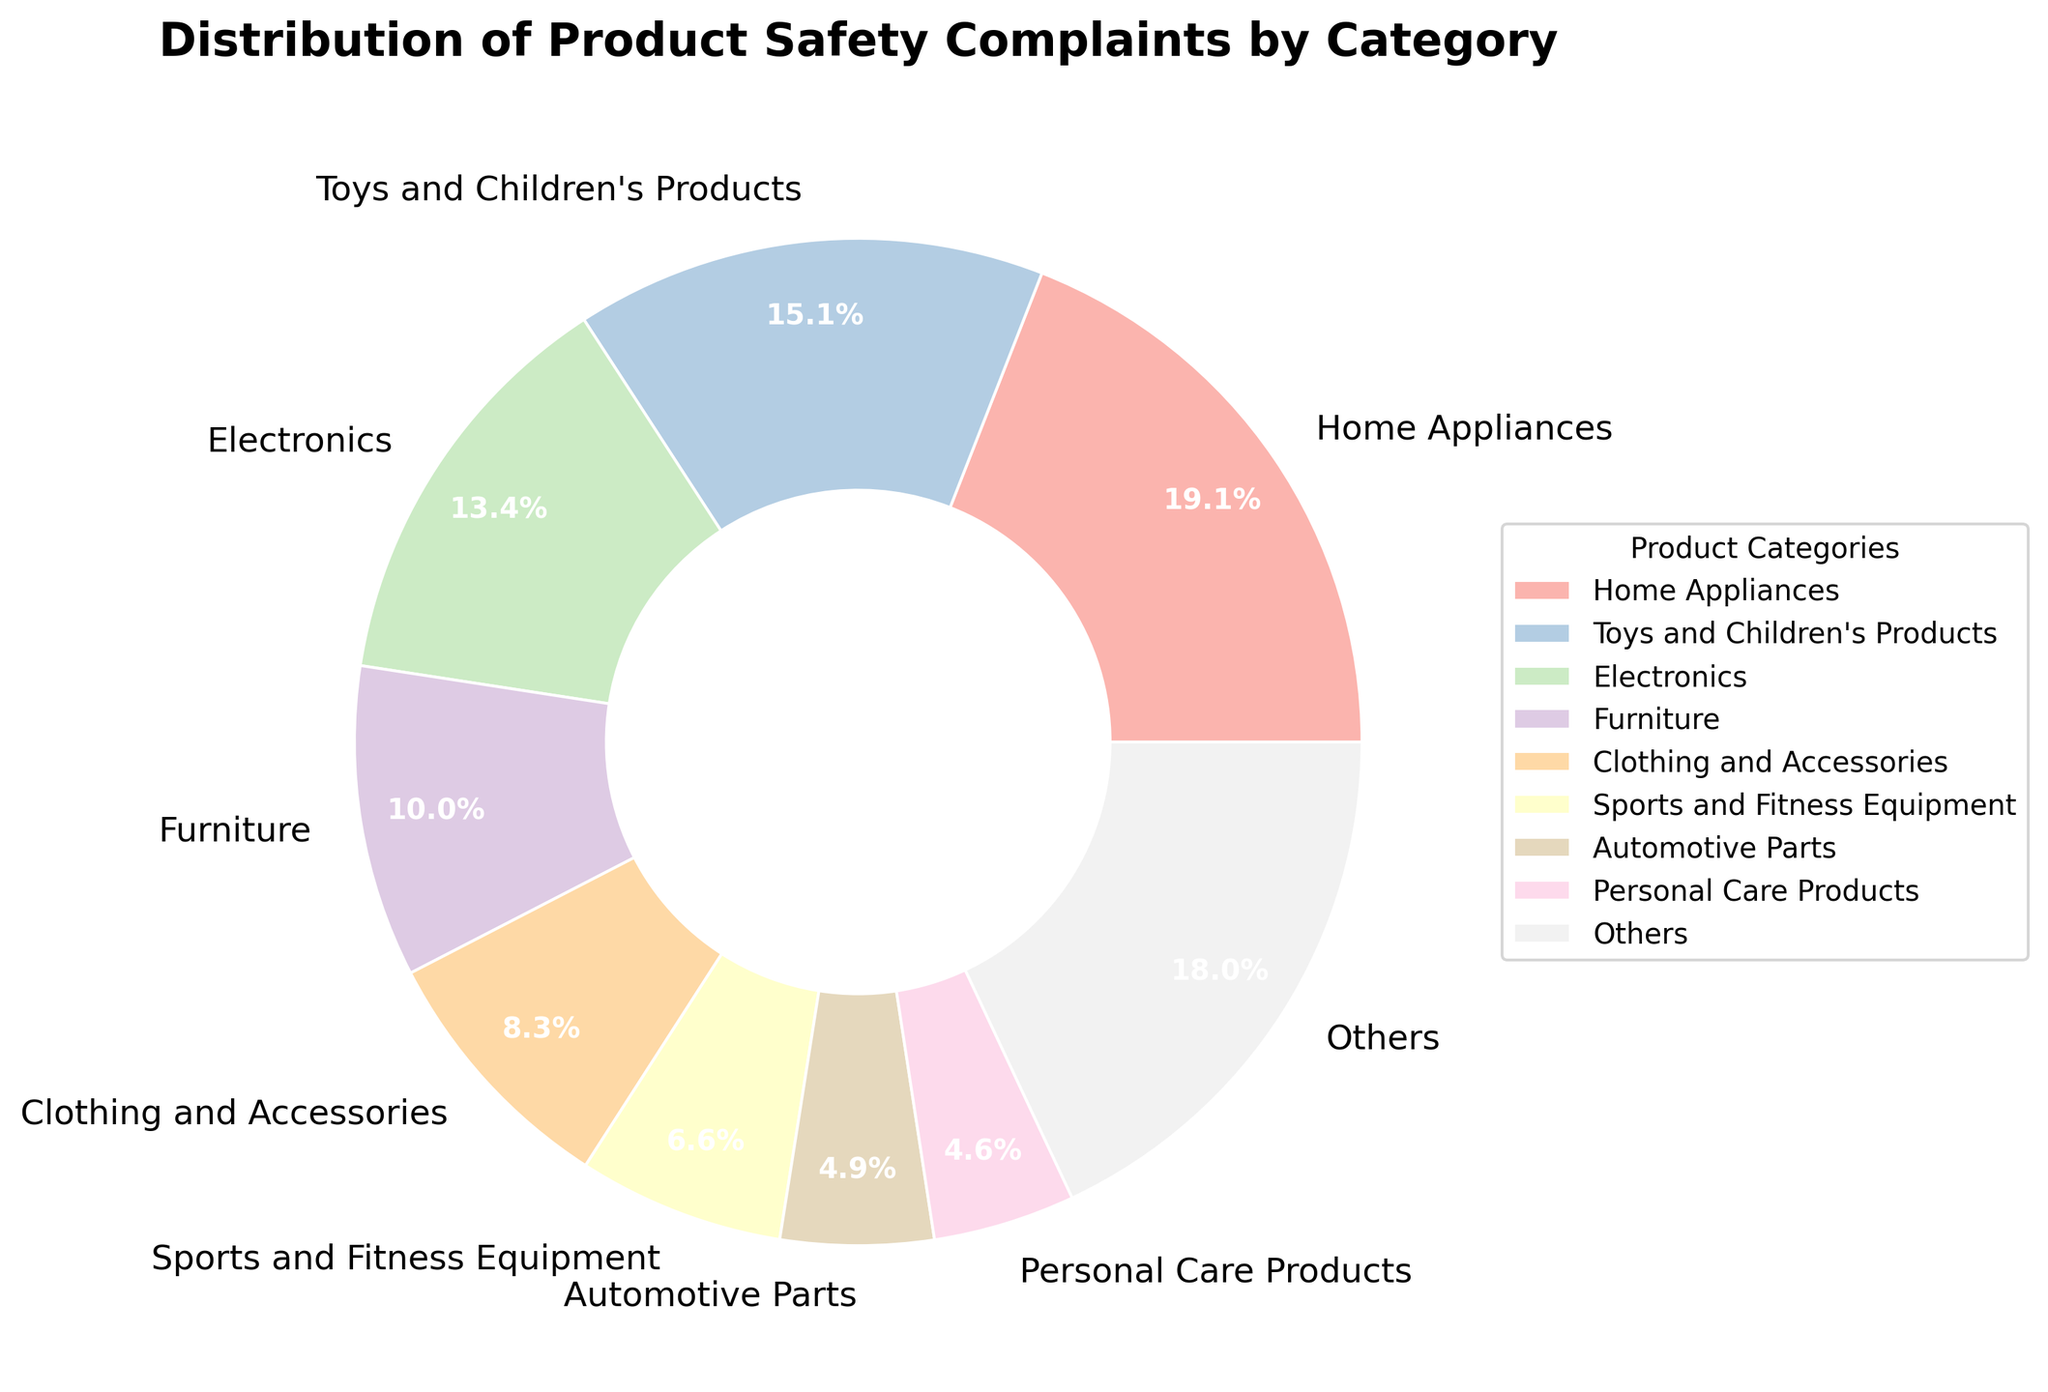Which product category has the highest number of safety complaints? To find which category has the highest number of safety complaints, look at the sector with the largest percentage in the pie chart. The "Home Appliances" category appears to have the largest segment.
Answer: Home Appliances What percentage of complaints are related to Electronics? To answer this, locate the "Electronics" segment in the pie chart. It's labeled with its percentage, allowing you to easily identify the answer.
Answer: 10.6% Which categories together make up for the "Others" category? To determine this, identify the top 8 categories in the pie chart. The remaining categories under "Others" are "Automotive Parts", "Personal Care Products", "Kitchen Utensils", "Tools and Hardware", "Outdoor and Garden Equipment", "Pet Products", "Food and Beverages", "Medical Devices", and "Cleaning Products".
Answer: Automotive Parts, Personal Care Products, Kitchen Utensils, Tools and Hardware, Outdoor and Garden Equipment, Pet Products, Food and Beverages, Medical Devices, Cleaning Products How does the number of complaints about Furniture compare to those about Clothing and Accessories? Compare the segments labeled "Furniture" and "Clothing and Accessories". The "Furniture" sector is larger, indicating a higher percentage.
Answer: Furniture has more complaints What is the sum of complaints for 'Sports and Fitness Equipment' and 'Automotive Parts'? Refer to the pie chart where "Sports and Fitness Equipment" is 5.2% and "Automotive Parts" is 3.9%. Adding these percentages together gives 9.1% of the total complaints.
Answer: 9.1% Are there more complaints related to 'Toys and Children's Products' or 'Medical Devices'? Compare the segments for "Toys and Children's Products" and "Medical Devices". The former has a significantly larger segment.
Answer: Toys and Children's Products What is the total percentage of complaints attributed to Home Appliances, Furniture, Clothing and Accessories, and Toys and Children's Products combined? Sum the percentages for "Home Appliances" (15.0%), "Furniture" (7.9%), "Clothing and Accessories" (6.5%), and "Toys and Children's Products" (11.9%). The sum is (15.0 + 7.9 + 6.5 + 11.9) = 41.3%.
Answer: 41.3% Among 'Outdoor and Garden Equipment' and 'Food and Beverages', which has a lower number of complaints? Compare the pie chart segments for "Outdoor and Garden Equipment" and "Food and Beverages". The "Food and Beverages" segment is smaller.
Answer: Food and Beverages What fraction of total complaints are attributed to 'Medical Devices'? Refer to the pie chart segment labeled "Medical Devices" which is 1.2%. The fraction of the total is therefore 1.2%.
Answer: 1.2% What are the top three categories with the most complaints? Identify the three largest segments in the pie chart. These are "Home Appliances", "Toys and Children's Products", and "Electronics".
Answer: Home Appliances, Toys and Children's Products, Electronics 